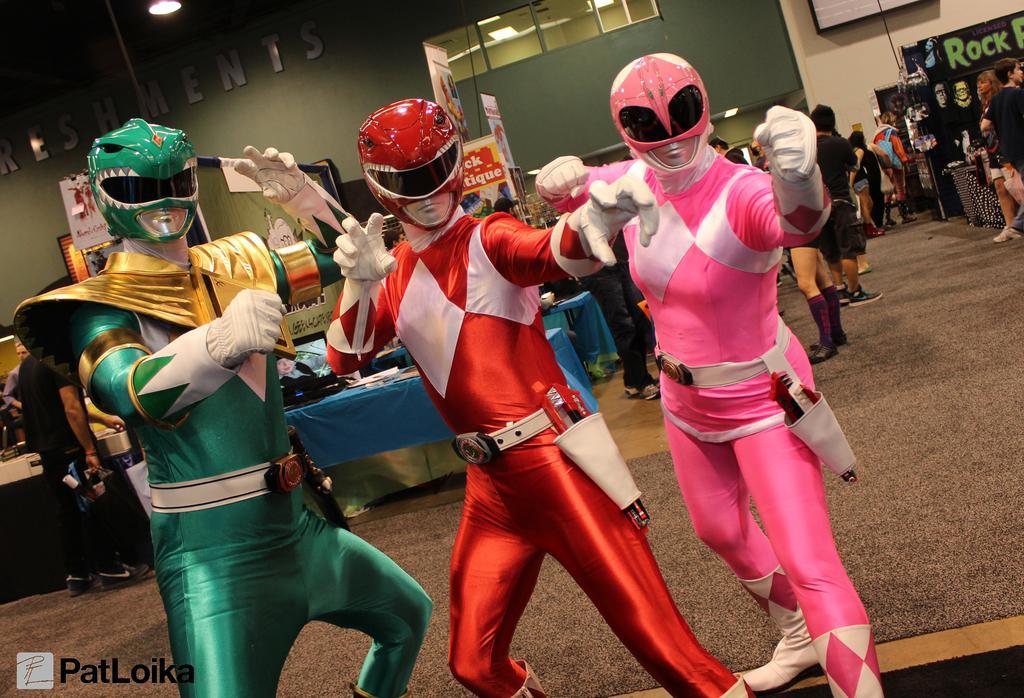In one or two sentences, can you explain what this image depicts? In the center of the image we can see three people standing. They are wearing costumes. In the background there are tables and we can see people. There are boards and we can see a wall. At the top there are lights and there are windows. 